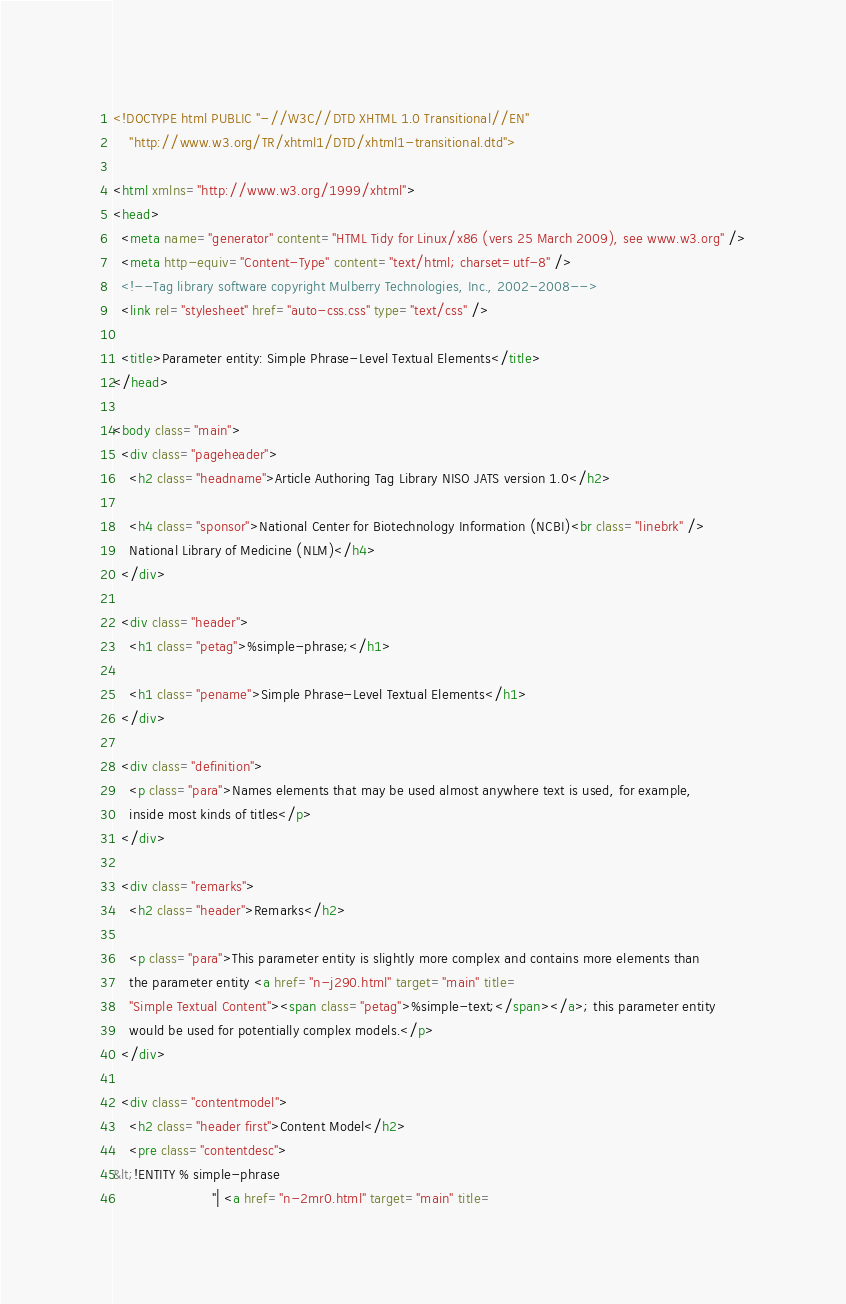Convert code to text. <code><loc_0><loc_0><loc_500><loc_500><_HTML_><!DOCTYPE html PUBLIC "-//W3C//DTD XHTML 1.0 Transitional//EN"
    "http://www.w3.org/TR/xhtml1/DTD/xhtml1-transitional.dtd">

<html xmlns="http://www.w3.org/1999/xhtml">
<head>
  <meta name="generator" content="HTML Tidy for Linux/x86 (vers 25 March 2009), see www.w3.org" />
  <meta http-equiv="Content-Type" content="text/html; charset=utf-8" />
  <!--Tag library software copyright Mulberry Technologies, Inc., 2002-2008-->
  <link rel="stylesheet" href="auto-css.css" type="text/css" />

  <title>Parameter entity: Simple Phrase-Level Textual Elements</title>
</head>

<body class="main">
  <div class="pageheader">
    <h2 class="headname">Article Authoring Tag Library NISO JATS version 1.0</h2>

    <h4 class="sponsor">National Center for Biotechnology Information (NCBI)<br class="linebrk" />
    National Library of Medicine (NLM)</h4>
  </div>

  <div class="header">
    <h1 class="petag">%simple-phrase;</h1>

    <h1 class="pename">Simple Phrase-Level Textual Elements</h1>
  </div>

  <div class="definition">
    <p class="para">Names elements that may be used almost anywhere text is used, for example,
    inside most kinds of titles</p>
  </div>

  <div class="remarks">
    <h2 class="header">Remarks</h2>

    <p class="para">This parameter entity is slightly more complex and contains more elements than
    the parameter entity <a href="n-j290.html" target="main" title=
    "Simple Textual Content"><span class="petag">%simple-text;</span></a>; this parameter entity
    would be used for potentially complex models.</p>
  </div>

  <div class="contentmodel">
    <h2 class="header first">Content Model</h2>
    <pre class="contentdesc">
&lt;!ENTITY % simple-phrase
                        "| <a href="n-2mr0.html" target="main" title=</code> 